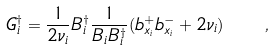<formula> <loc_0><loc_0><loc_500><loc_500>G _ { i } ^ { \dagger } = \frac { 1 } { 2 \nu _ { i } } B _ { i } ^ { \dagger } \frac { 1 } { B _ { i } B _ { i } ^ { \dagger } } ( b _ { x _ { i } } ^ { + } b _ { x _ { i } } ^ { - } + 2 \nu _ { i } ) \quad ,</formula> 